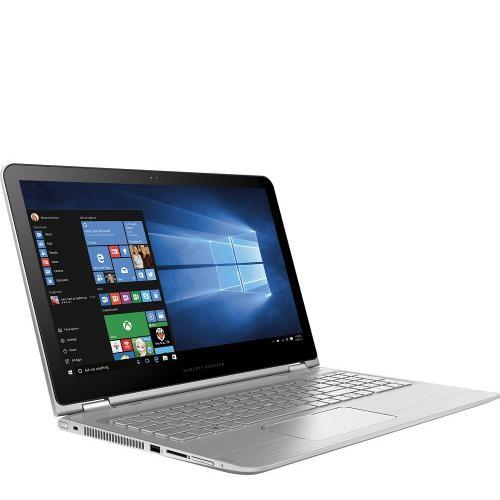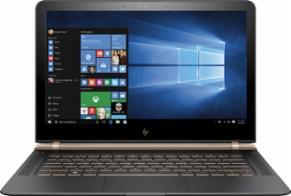The first image is the image on the left, the second image is the image on the right. Evaluate the accuracy of this statement regarding the images: "There is at least one human hand that is at least partially visible". Is it true? Answer yes or no. No. The first image is the image on the left, the second image is the image on the right. Examine the images to the left and right. Is the description "Human hands are near a keyboard in one image." accurate? Answer yes or no. No. 